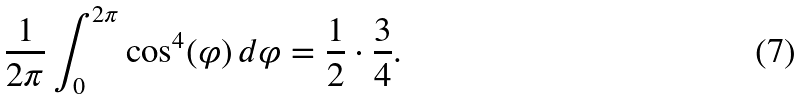Convert formula to latex. <formula><loc_0><loc_0><loc_500><loc_500>\frac { 1 } { 2 \pi } \int _ { 0 } ^ { 2 \pi } \cos ^ { 4 } ( \varphi ) \, d \varphi = \frac { 1 } { 2 } \cdot \frac { 3 } { 4 } .</formula> 